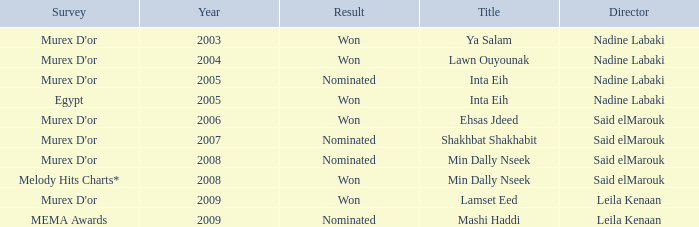What survey has the Ehsas Jdeed title? Murex D'or. 